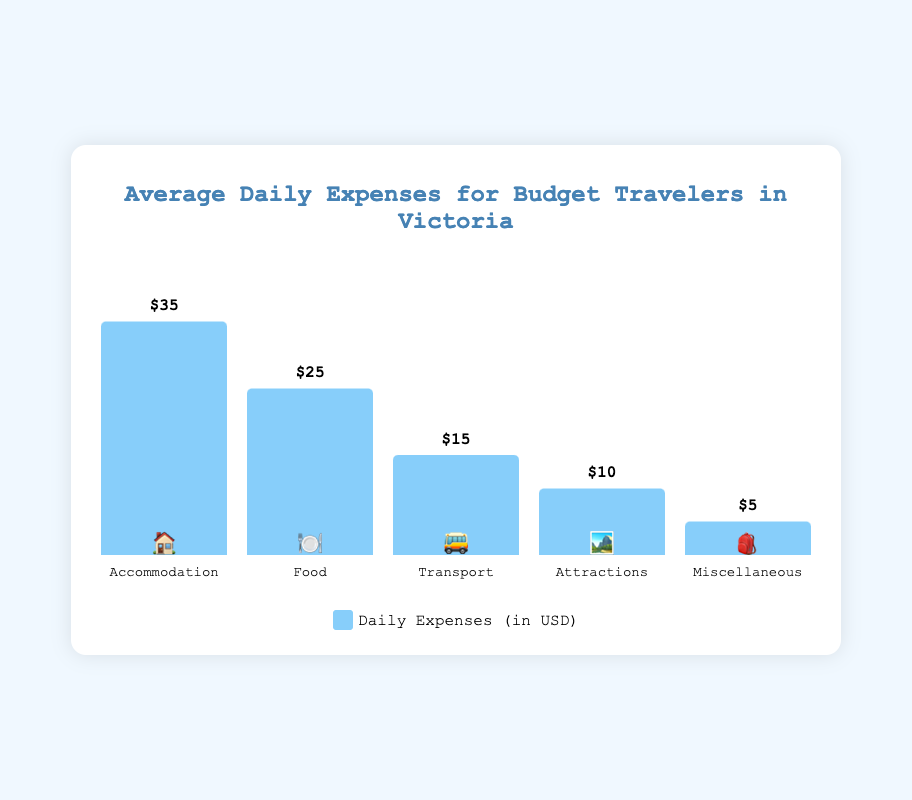What's the title of the chart? The title is located at the top of the chart, usually in a larger, bold font. It provides a summary of what the chart is about.
Answer: Average Daily Expenses for Budget Travelers in Victoria Which category has the highest daily cost? By looking at the height of each bar, the tallest bar represents the category with the highest daily cost.
Answer: 🏠 Accommodation What is the total average daily expense for a budget traveler in Victoria? Sum the costs of all categories: $35 (Accommodation) + $25 (Food) + $15 (Transport) + $10 (Attractions) + $5 (Miscellaneous).
Answer: $90 How much more is spent on food compared to transport? Calculate the difference between the cost of food and transport: $25 (Food) - $15 (Transport).
Answer: $10 Which category has the lowest daily cost? Identifying the shortest bar in the chart, which represents the category with the lowest cost.
Answer: 🎒 Miscellaneous What is the average cost of Accommodation and Food combined? Sum the costs of Accommodation and Food, then divide by 2: ($35 + $25) / 2.
Answer: $30 Is the daily cost for Attractions greater than half the daily cost for Accommodation? Half the cost of Accommodation is $35 / 2 = $17.50. Compare this with the cost of Attractions which is $10.
Answer: No Compare the total daily expense for Transport and Attractions to the daily cost of Accommodation. Which is higher? Sum the costs of Transport and Attractions ($15 + $10 = $25) and compare with the cost of Accommodation ($35).
Answer: Accommodation What is the combined cost of all categories except for Food? Sum the costs of all categories except Food: $35 (Accommodation) + $15 (Transport) + $10 (Attractions) + $5 (Miscellaneous).
Answer: $65 How does the cost of Miscellaneous compare to the cost of Attractions? Compare the cost values directly: $10 (Attractions) and $5 (Miscellaneous).
Answer: Miscellaneous is less 